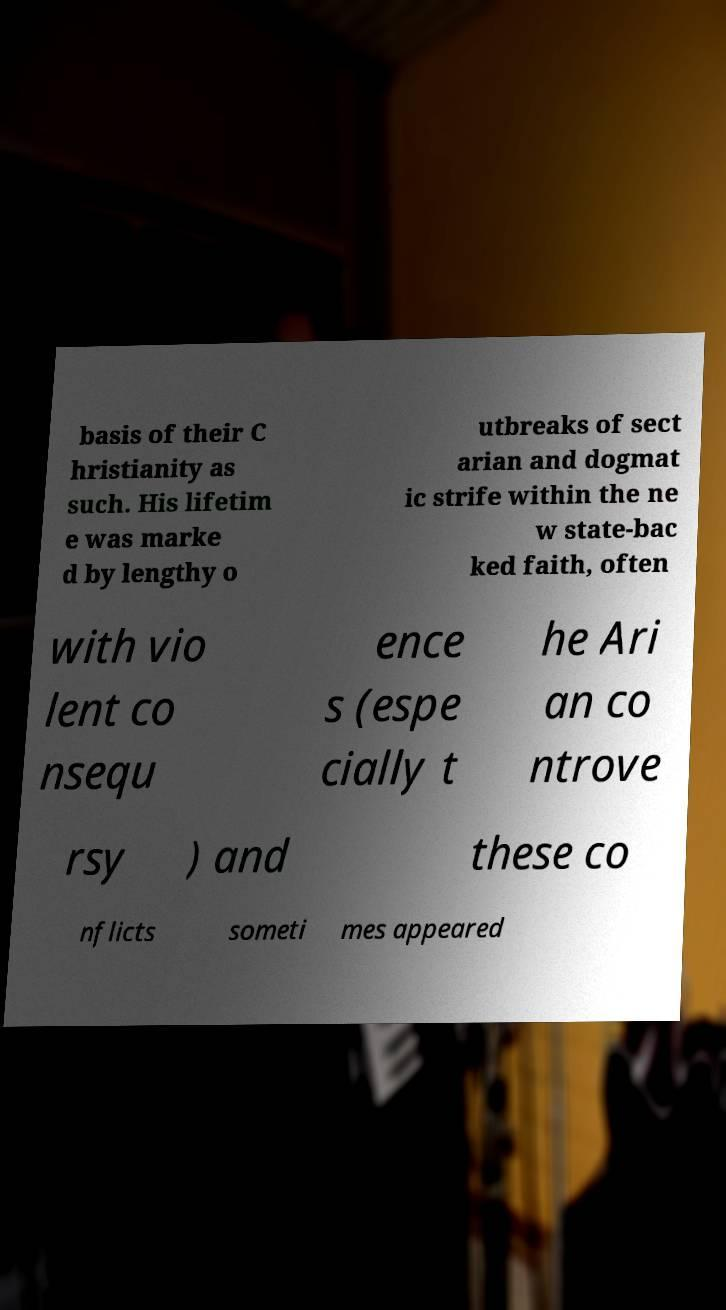Could you assist in decoding the text presented in this image and type it out clearly? basis of their C hristianity as such. His lifetim e was marke d by lengthy o utbreaks of sect arian and dogmat ic strife within the ne w state-bac ked faith, often with vio lent co nsequ ence s (espe cially t he Ari an co ntrove rsy ) and these co nflicts someti mes appeared 